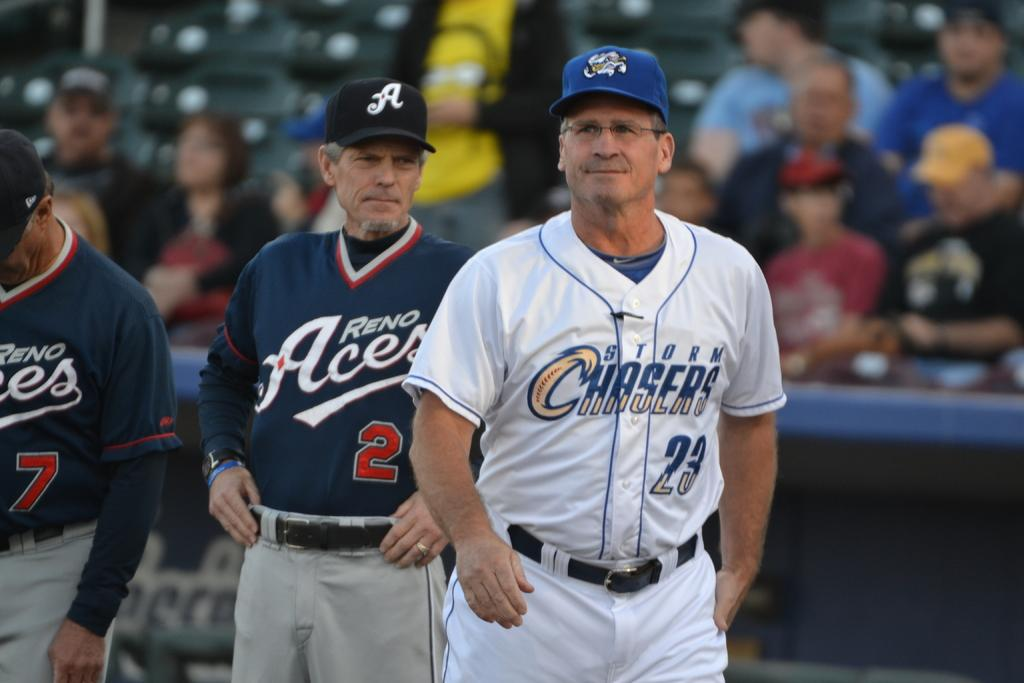Provide a one-sentence caption for the provided image. people in sports uniforms for Reno Aces and Storm Chasers on a field. 